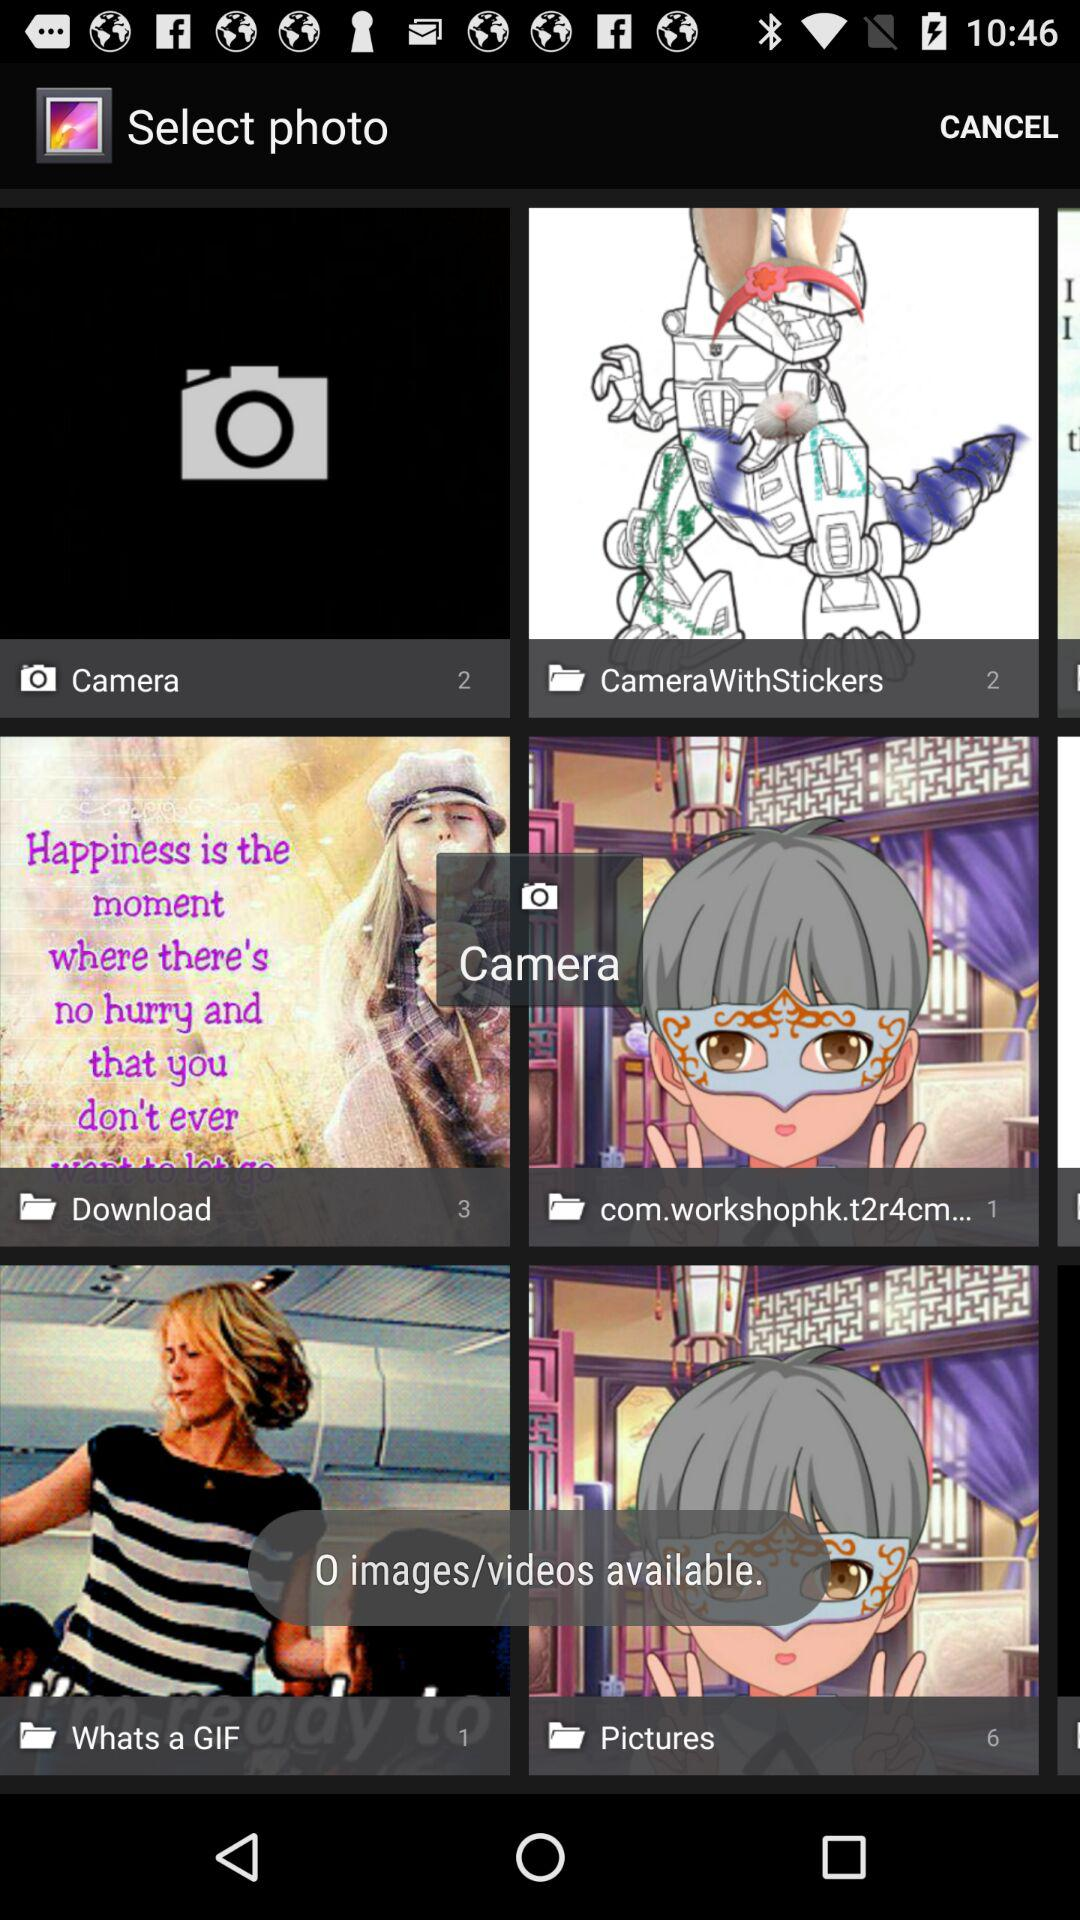How many pictures are in the "Download" folder? There are 3 pictures in the "Download" folder. 